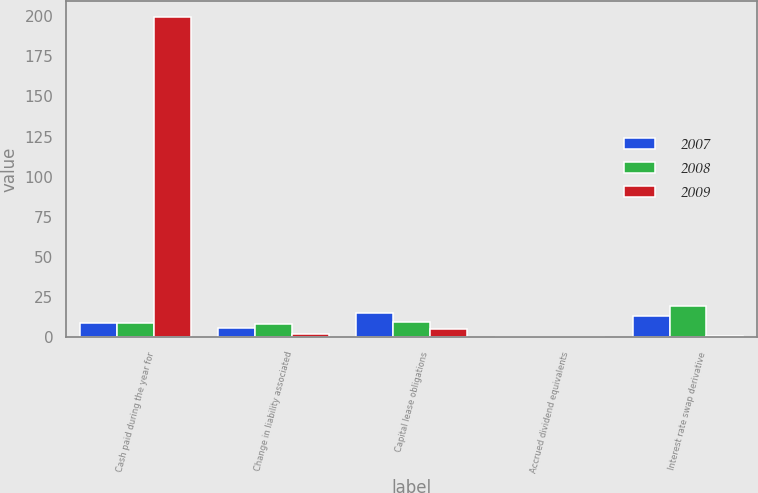<chart> <loc_0><loc_0><loc_500><loc_500><stacked_bar_chart><ecel><fcel>Cash paid during the year for<fcel>Change in liability associated<fcel>Capital lease obligations<fcel>Accrued dividend equivalents<fcel>Interest rate swap derivative<nl><fcel>2007<fcel>9<fcel>5.9<fcel>15.5<fcel>0.1<fcel>13.6<nl><fcel>2008<fcel>9<fcel>8.3<fcel>9.7<fcel>0.2<fcel>19.5<nl><fcel>2009<fcel>199.6<fcel>2.1<fcel>5.1<fcel>0.2<fcel>0.6<nl></chart> 